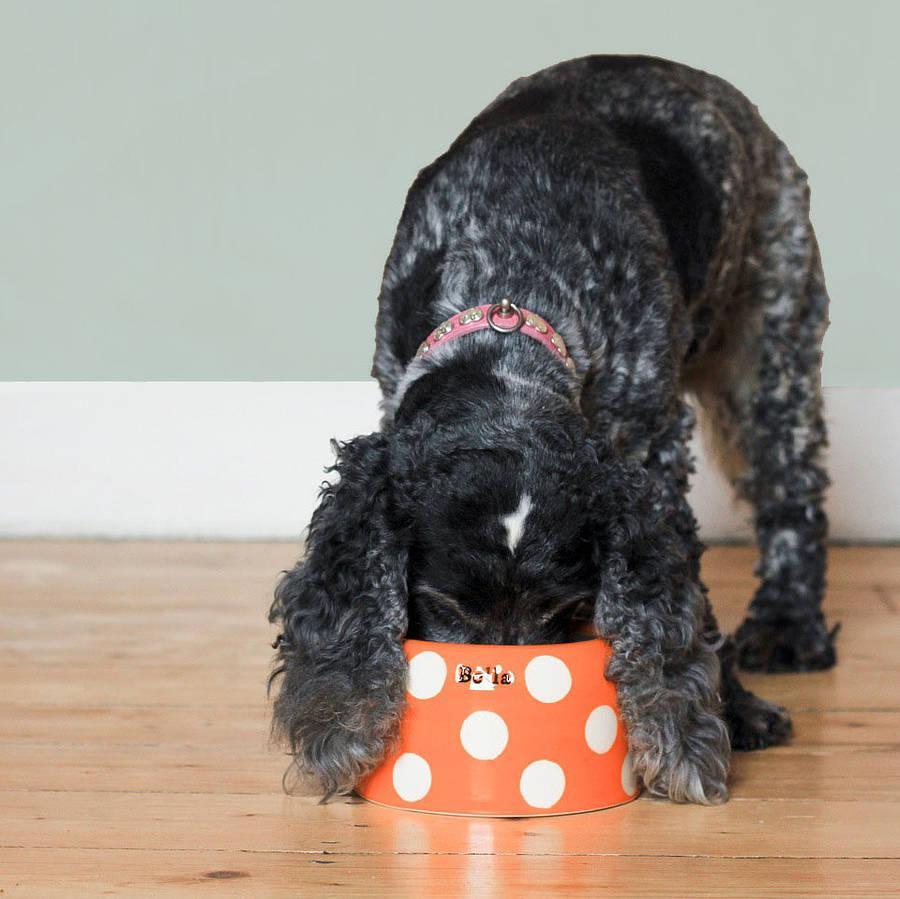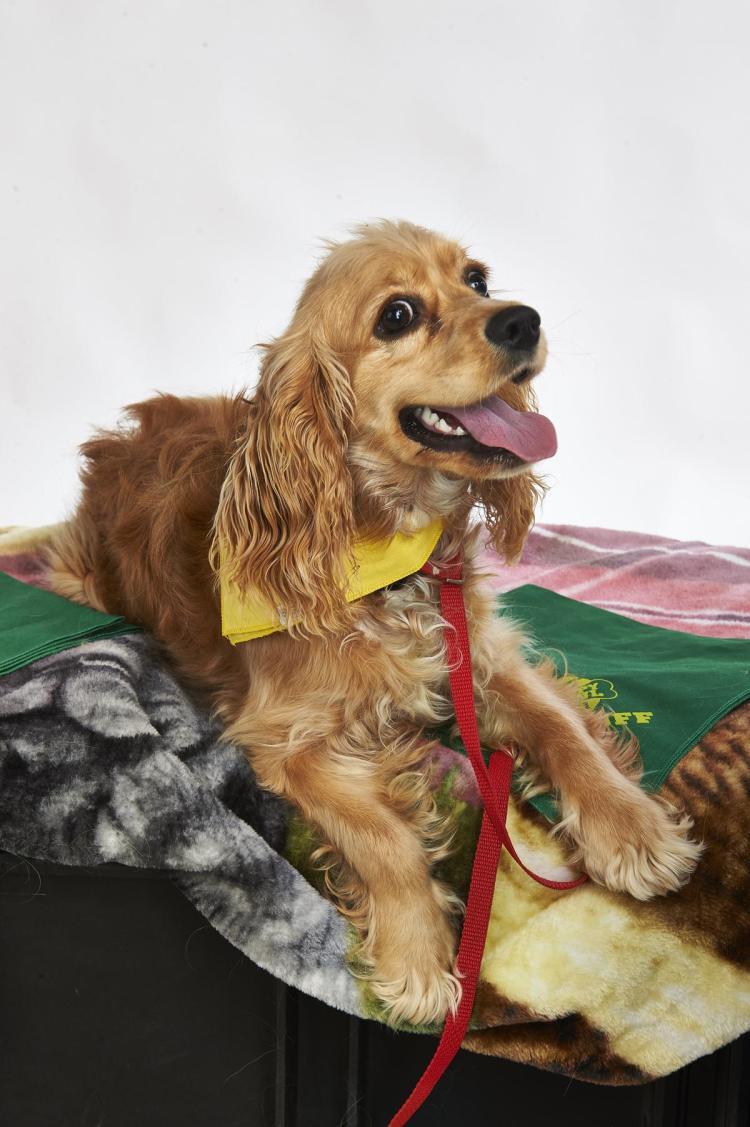The first image is the image on the left, the second image is the image on the right. Considering the images on both sides, is "The dog in the image on the left is eating out of a bowl." valid? Answer yes or no. Yes. The first image is the image on the left, the second image is the image on the right. Considering the images on both sides, is "An image includes an orange cocker spaniel with its nose in a dog bowl without a patterned design." valid? Answer yes or no. No. 